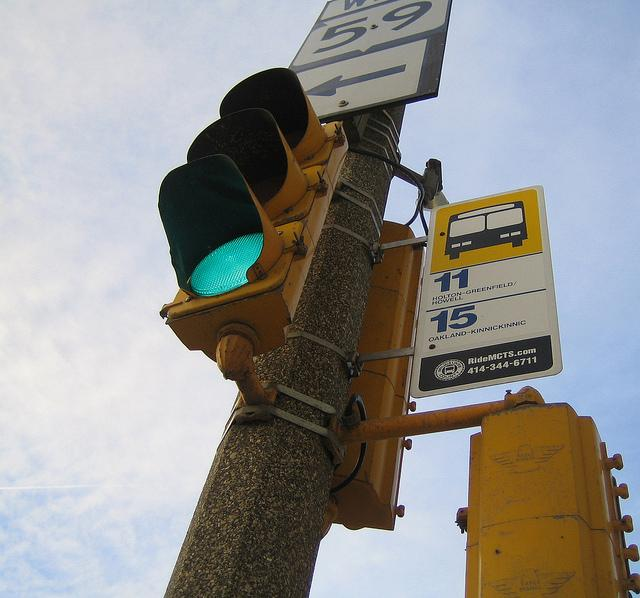What is the largest of the blue numbers on the sign? Please explain your reasoning. 15. The other one is 11 